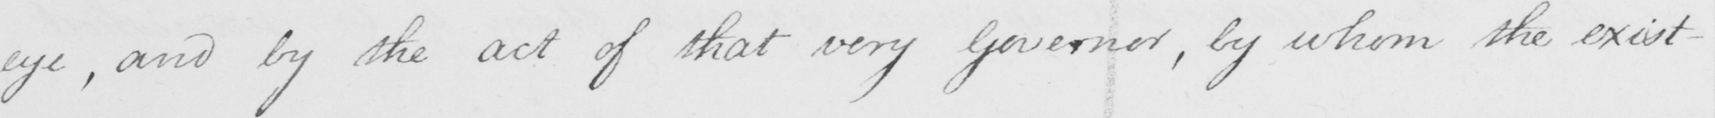Can you tell me what this handwritten text says? eye , and by the act of that very Governor , by whom the exist- 